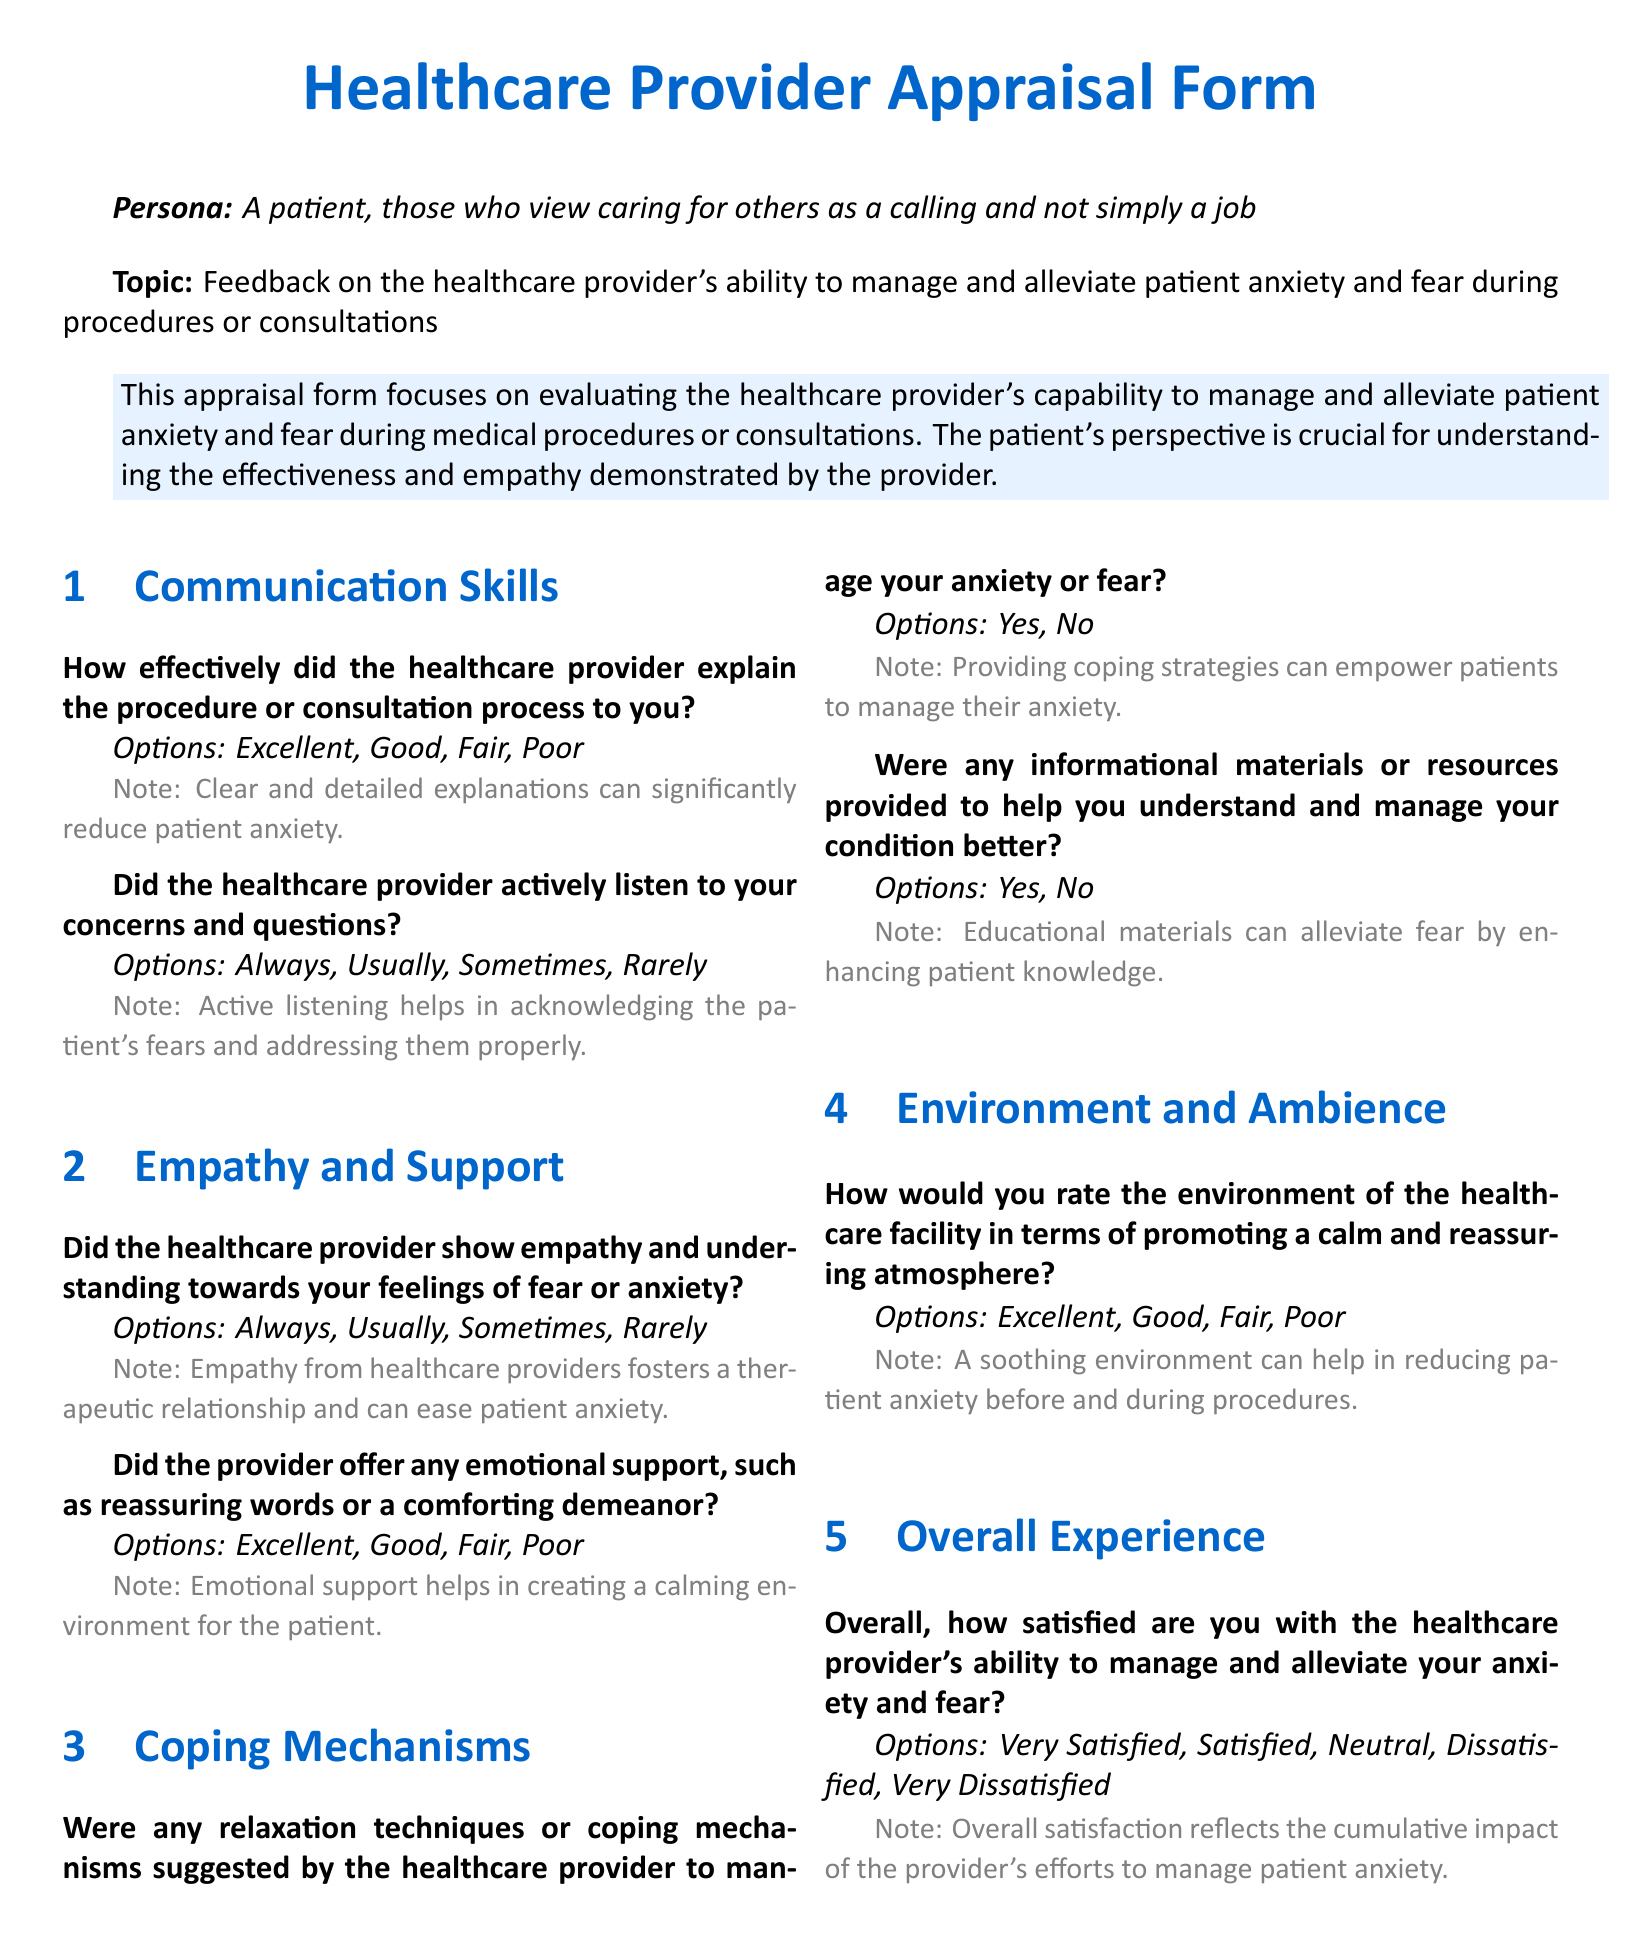What is the title of the document? The title of the document is prominently displayed at the beginning.
Answer: Healthcare Provider Appraisal Form What is the topic of the appraisal form? The topic is mentioned right after the persona description.
Answer: Feedback on the healthcare provider's ability to manage and alleviate patient anxiety and fear during procedures or consultations What are the options provided for the overall satisfaction question? The options are listed under the Overall Experience section.
Answer: Very Satisfied, Satisfied, Neutral, Dissatisfied, Very Dissatisfied How many sections are there in the document? The sections are clearly defined within the document and can be counted.
Answer: Four What does the appraisal form focus on? The focus of the appraisal form is stated in the colored box.
Answer: Evaluating the healthcare provider's capability to manage and alleviate patient anxiety and fear during medical procedures or consultations Did the form include a question about providing relaxation techniques? The question is explicitly listed under Coping Mechanisms.
Answer: Yes 